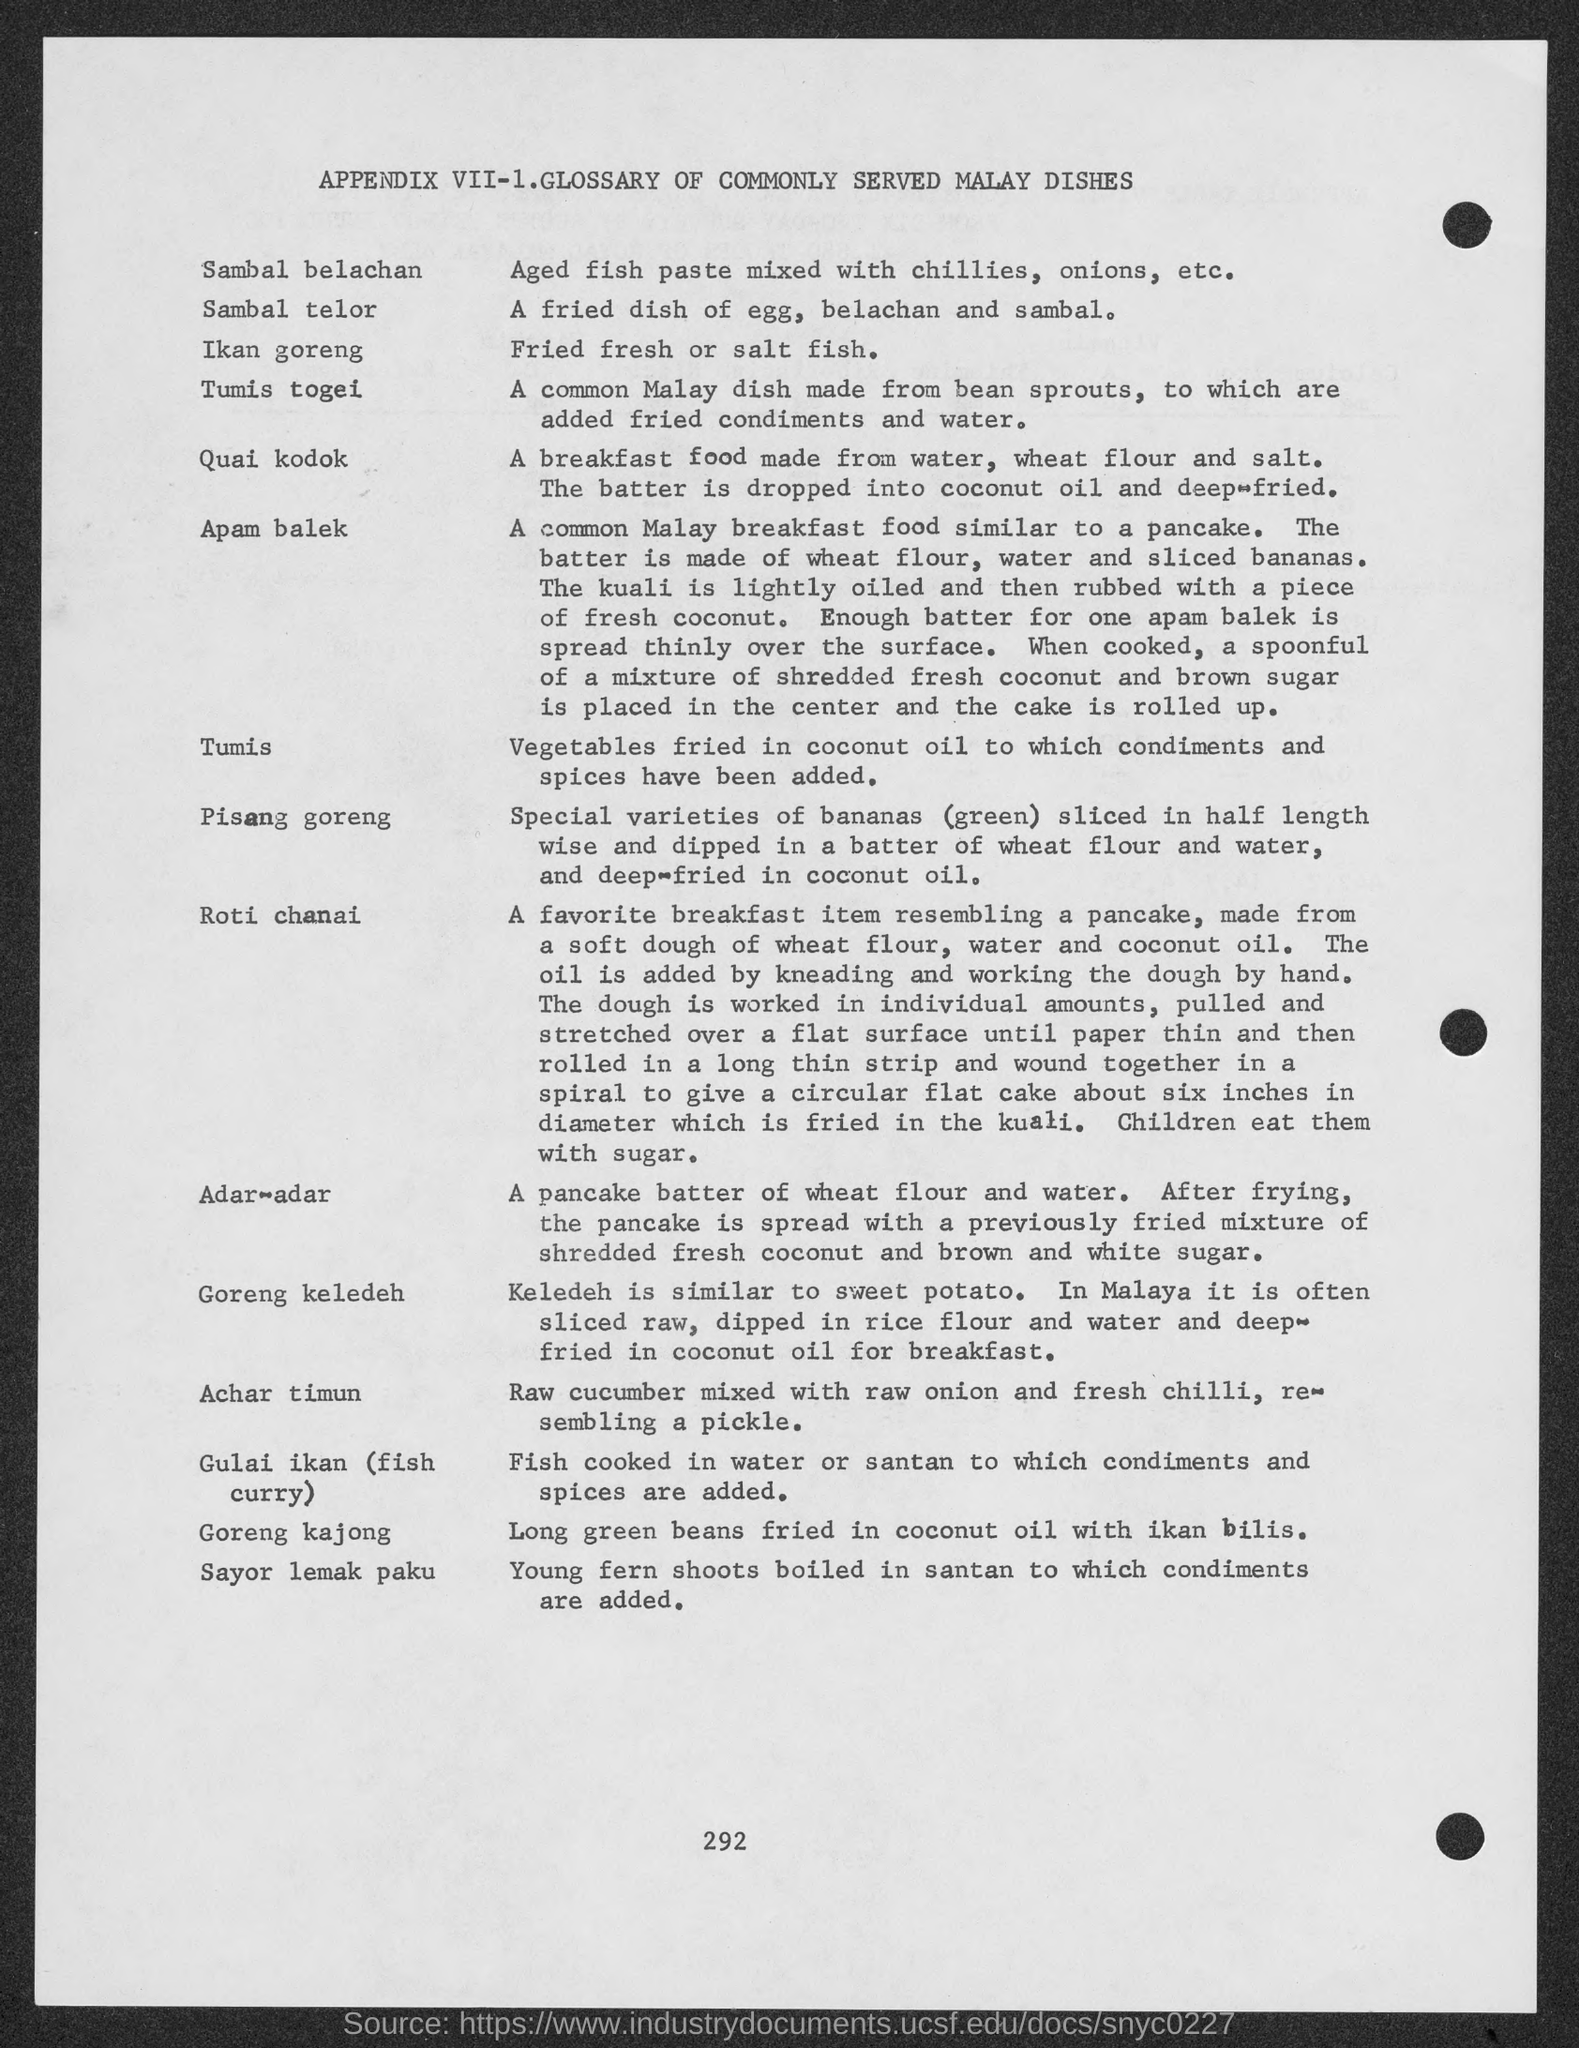Specify some key components in this picture. Sambal belachan is a type of aged fish paste that is mixed with chillies, onions, and other spices to create a flavorful condiment. Sambal Telor is a fried dish in which eggs, belachan, and sambal are used as ingredients. 